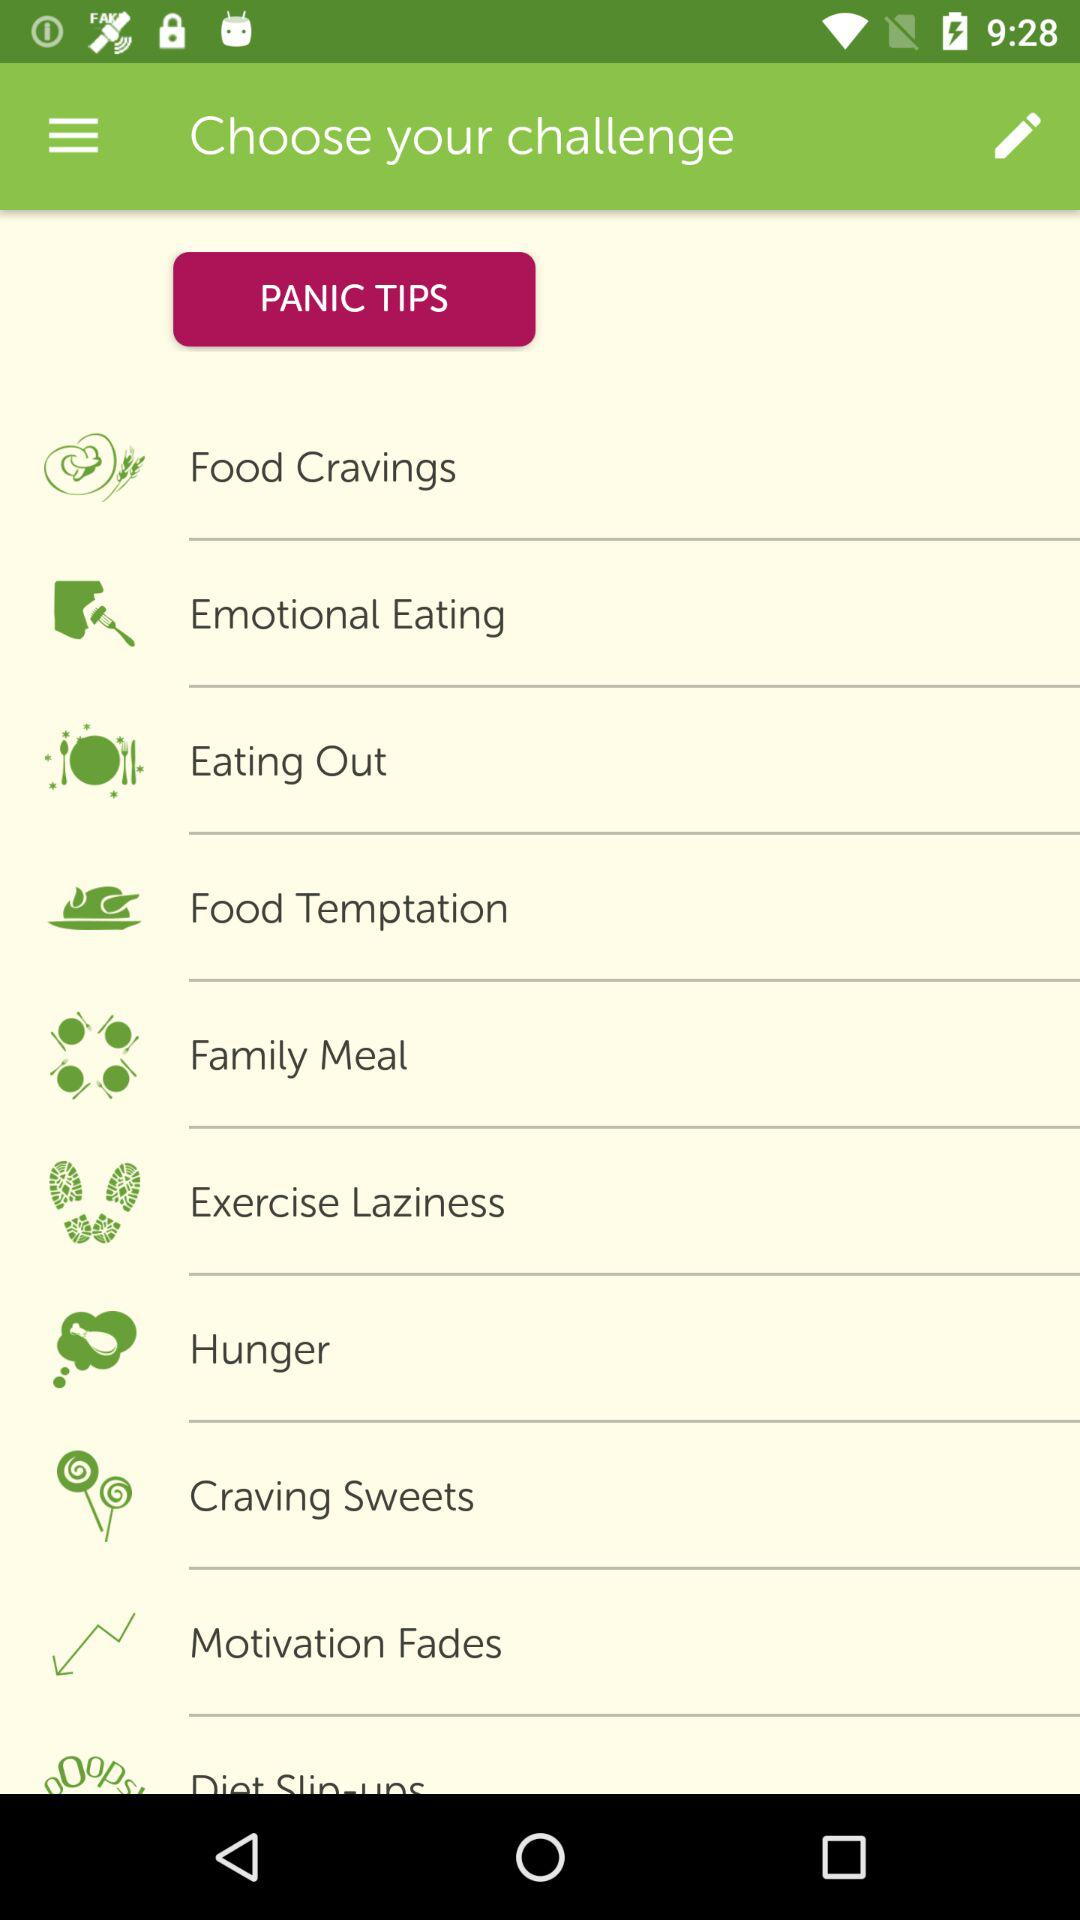How many challenges are there?
Answer the question using a single word or phrase. 10 